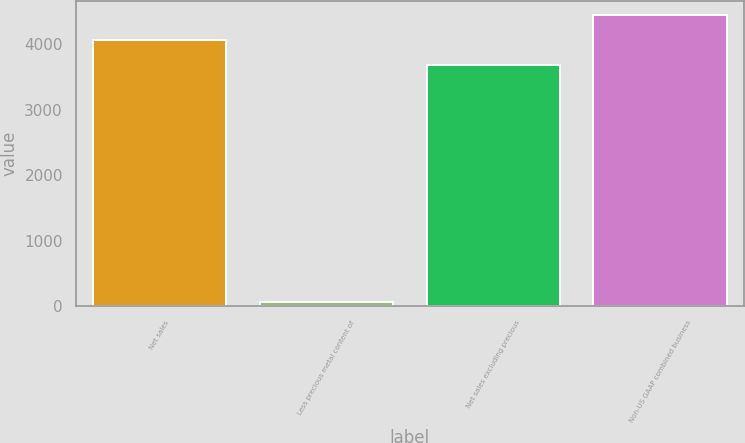Convert chart. <chart><loc_0><loc_0><loc_500><loc_500><bar_chart><fcel>Net sales<fcel>Less precious metal content of<fcel>Net sales excluding precious<fcel>Non-US GAAP combined business<nl><fcel>4060.04<fcel>64.3<fcel>3681<fcel>4439.08<nl></chart> 